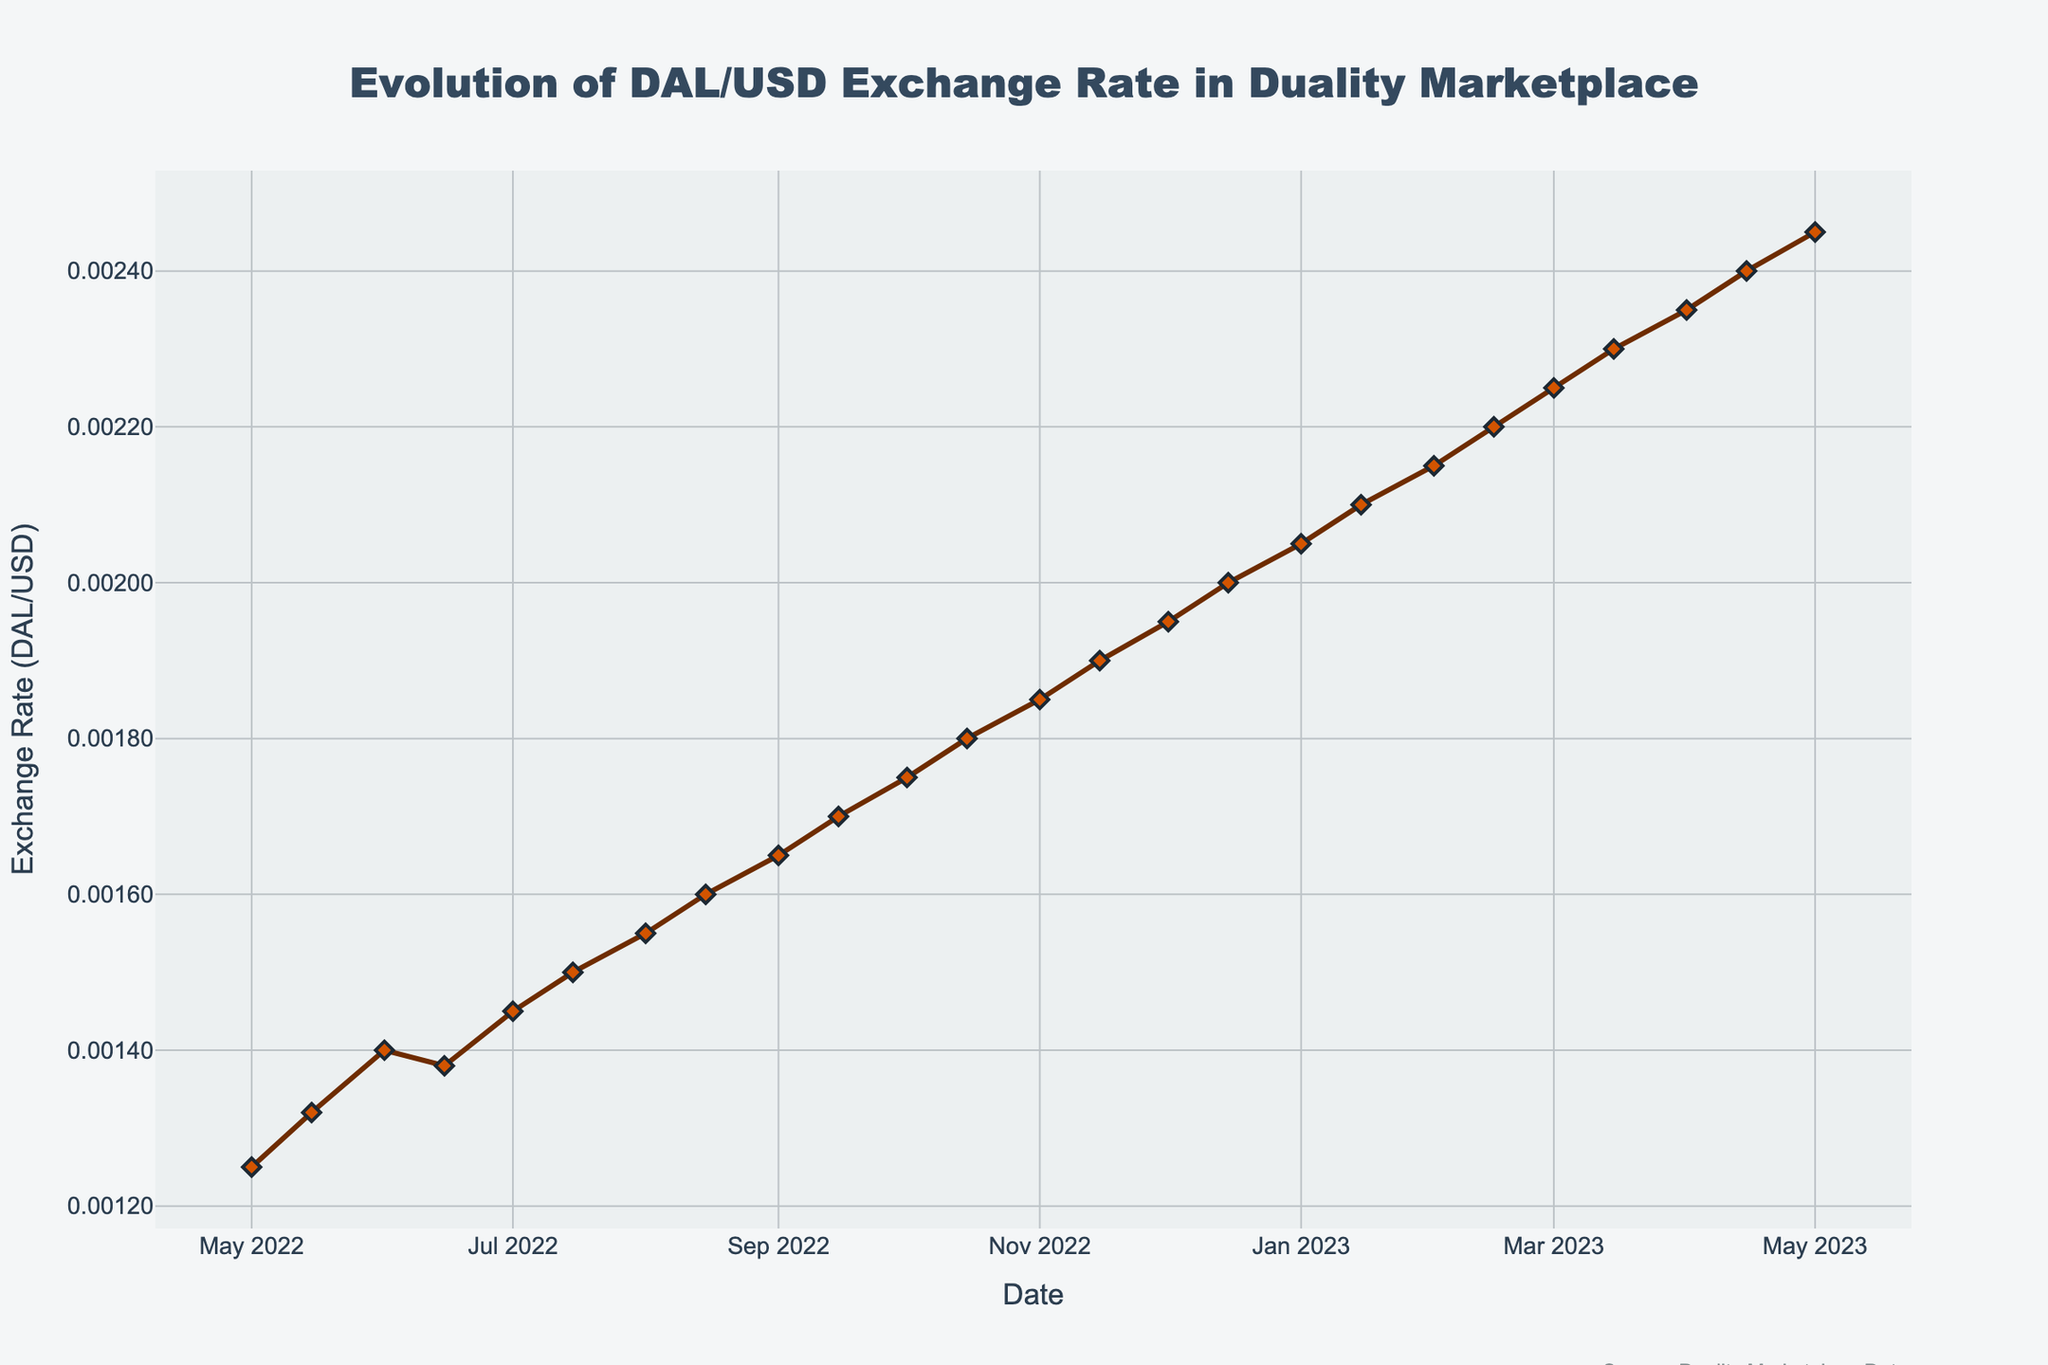When did the exchange rate first reach 0.00200? Looking at the chart, the first occurrence of the exchange rate 0.00200 happens around mid-December 2022.
Answer: December 15, 2022 What was the exchange rate on January 1, 2023? By identifying the date January 1, 2023 on the x-axis and moving vertically to the data point, one can observe that the exchange rate on that date was approximately 0.00205.
Answer: 0.00205 By how much did the exchange rate increase from August 1, 2022 to September 1, 2022? Locate the points for August 1, 2022 and September 1, 2022 on the chart. The exchange rate on August 1, 2022 was 0.00155, and on September 1, 2022 it was 0.00165. Thus, the increase is 0.00165 - 0.00155 = 0.00010
Answer: 0.00010 Compare the exchange rate between February 15 and April 15 of 2023. Which date had a higher rate? Identify the points for February 15, 2023 and April 15, 2023. On February 15, the rate is 0.00220, and on April 15, it is 0.00240. Since 0.00240 is higher than 0.00220, April 15, 2023 had a higher rate.
Answer: April 15, 2023 What is the difference in exchange rates between the dates October 1, 2022 and May 1, 2023? The exchange rate on October 1, 2022 is 0.00175, and on May 1, 2023 it is 0.00245. Therefore, the difference is 0.00245 - 0.00175 = 0.00070.
Answer: 0.00070 Which month observed the highest increase in exchange rate from its starting value to its ending value? By checking each month, observe the rate changes at the start and end of each month. The month with the largest increase is identified by comparing these increases. August 2022 shows a start of 0.00155 and an end of 0.00160, which is one of the largest increases of 0.00005 in a short period.
Answer: August 2022 What was the trend of the exchange rate from November 2022 to February 2023? Review the general direction of the line connecting November 2022 through February 2023. The trend is consistently increasing, as each point in the sequence is higher than the last.
Answer: Increasing Determine the mean exchange rate for the dates October 15, 2022 and January 15, 2023. The rate on October 15, 2022 is 0.00180, and on January 15, 2023 it is 0.00210. The mean is calculated by (0.00180 + 0.00210) / 2 = 0.00195.
Answer: 0.00195 